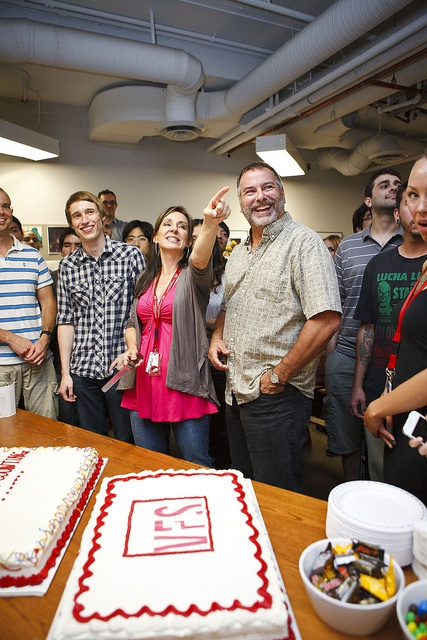Describe the objects in this image and their specific colors. I can see dining table in black, white, red, orange, and lightpink tones, cake in black, white, brown, lightpink, and darkgray tones, people in black, lightgray, and darkgray tones, people in black, gray, and brown tones, and people in black, darkgray, gray, and lightgray tones in this image. 